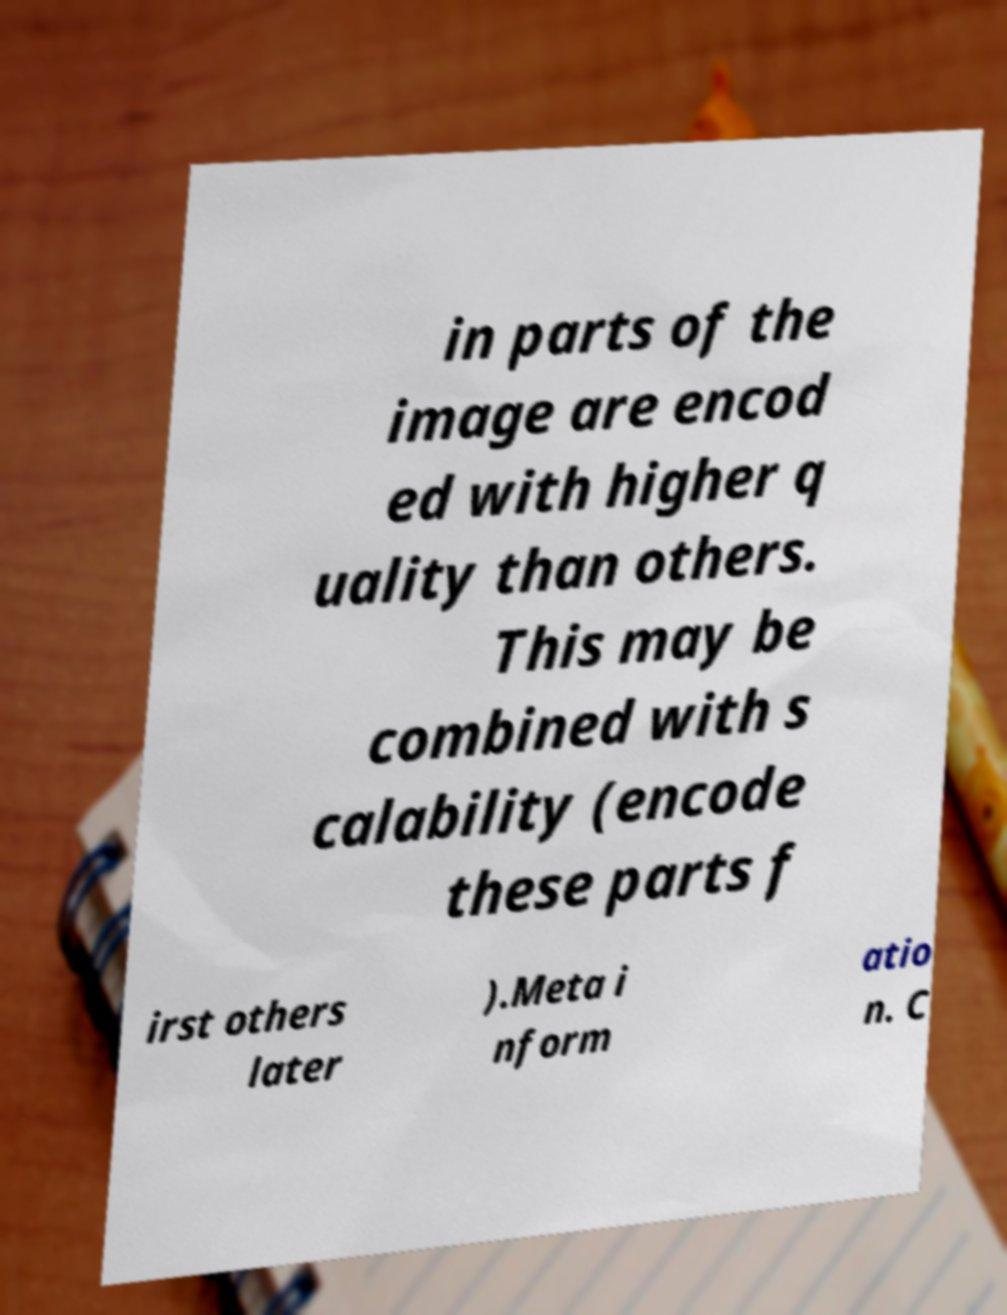What messages or text are displayed in this image? I need them in a readable, typed format. in parts of the image are encod ed with higher q uality than others. This may be combined with s calability (encode these parts f irst others later ).Meta i nform atio n. C 